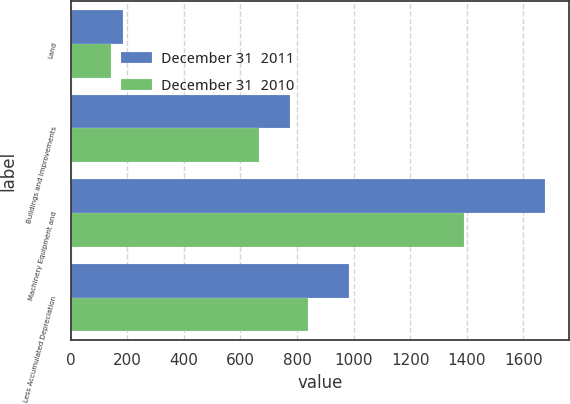<chart> <loc_0><loc_0><loc_500><loc_500><stacked_bar_chart><ecel><fcel>Land<fcel>Buildings and Improvements<fcel>Machinery Equipment and<fcel>Less Accumulated Depreciation<nl><fcel>December 31  2011<fcel>185.5<fcel>775.9<fcel>1677.4<fcel>982.6<nl><fcel>December 31  2010<fcel>142.9<fcel>667.4<fcel>1388.9<fcel>839<nl></chart> 